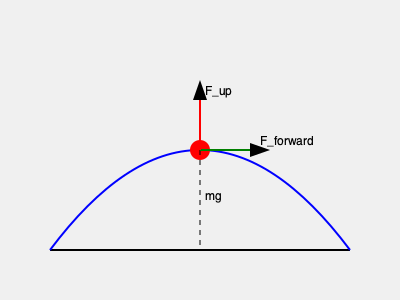In the context of designing fluid parkour mechanics, analyze the force diagram shown above for a player at the apex of a jump. If the player's mass is $m$ and the gravitational acceleration is $g$, determine the magnitude and direction of the resultant force $\vec{F}_R$ that should be applied to maintain a smooth, arc-like trajectory. Express your answer in terms of $m$, $g$, and the given forces $\vec{F}_{forward}$ and $\vec{F}_{up}$. To solve this problem, we'll follow these steps:

1) Identify the forces acting on the player:
   - Weight: $\vec{F}_g = m\vec{g}$ (downward)
   - Forward force: $\vec{F}_{forward}$ (horizontal)
   - Upward force: $\vec{F}_{up}$ (vertical)

2) The resultant force $\vec{F}_R$ is the vector sum of all forces:
   $$\vec{F}_R = \vec{F}_{forward} + \vec{F}_{up} + \vec{F}_g$$

3) Break down the forces into x and y components:
   x-component: $F_{Rx} = F_{forward}$
   y-component: $F_{Ry} = F_{up} - mg$

4) The magnitude of $\vec{F}_R$ can be calculated using the Pythagorean theorem:
   $$|\vec{F}_R| = \sqrt{F_{Rx}^2 + F_{Ry}^2} = \sqrt{F_{forward}^2 + (F_{up} - mg)^2}$$

5) The direction of $\vec{F}_R$ can be determined using the arctangent function:
   $$\theta = \arctan\left(\frac{F_{Ry}}{F_{Rx}}\right) = \arctan\left(\frac{F_{up} - mg}{F_{forward}}\right)$$

6) For a smooth, arc-like trajectory at the apex of the jump, $\vec{F}_R$ should be tangent to the path. This means $F_{up}$ should be equal to $mg$ to counteract gravity, and $F_{forward}$ should be non-zero to maintain horizontal motion.

7) Under these conditions, the resultant force simplifies to:
   $$\vec{F}_R = \vec{F}_{forward}$$

Thus, the magnitude of $\vec{F}_R$ is equal to $F_{forward}$, and its direction is horizontal (parallel to the ground).
Answer: $|\vec{F}_R| = F_{forward}$, direction: horizontal 